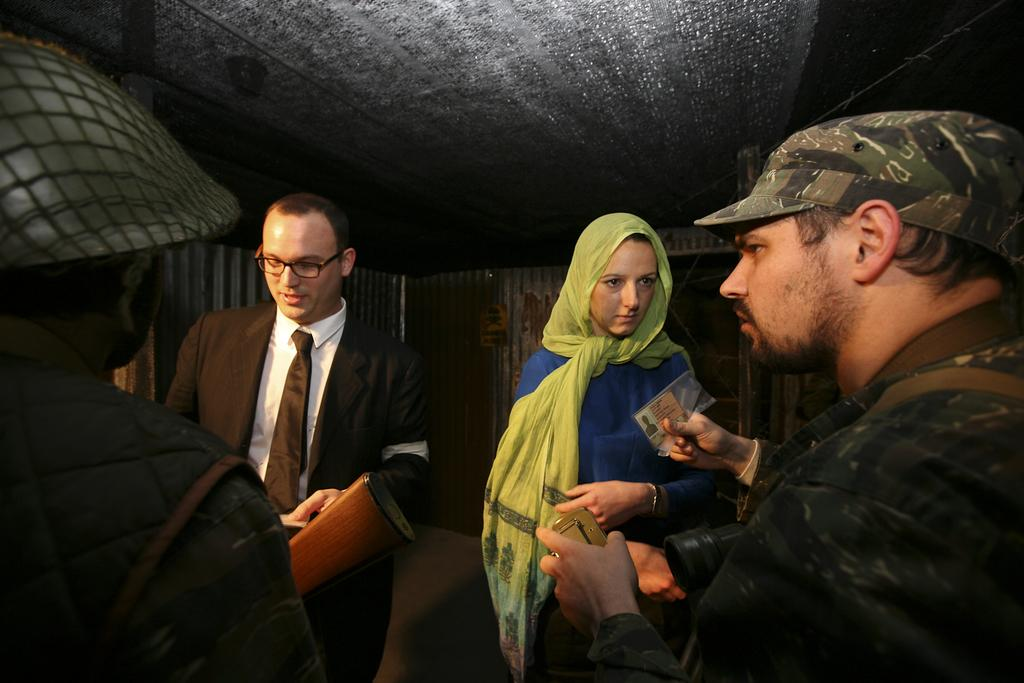How many persons are in the image? There are persons in the image, but the exact number is not specified. What are the persons doing in the image? Some of the persons are holding objects, but their specific actions are not described. What can be seen in the background of the image? There is a wall in the background of the image. What is visible at the top of the image? There is a roof visible at the top of the image. Can you see any branches in the image? There is no mention of branches in the provided facts, so we cannot determine if any are present in the image. 